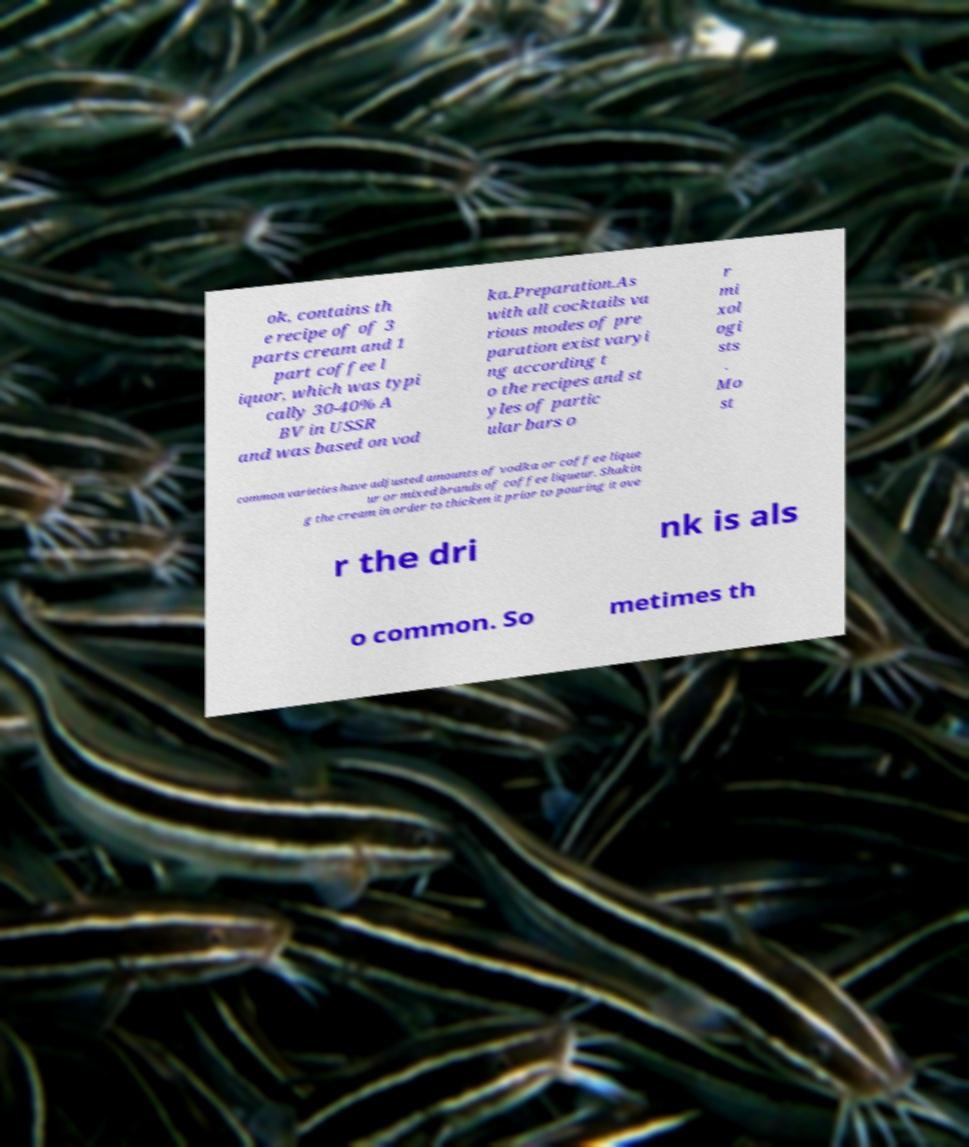Can you read and provide the text displayed in the image?This photo seems to have some interesting text. Can you extract and type it out for me? ok, contains th e recipe of of 3 parts cream and 1 part coffee l iquor, which was typi cally 30-40% A BV in USSR and was based on vod ka.Preparation.As with all cocktails va rious modes of pre paration exist varyi ng according t o the recipes and st yles of partic ular bars o r mi xol ogi sts . Mo st common varieties have adjusted amounts of vodka or coffee lique ur or mixed brands of coffee liqueur. Shakin g the cream in order to thicken it prior to pouring it ove r the dri nk is als o common. So metimes th 